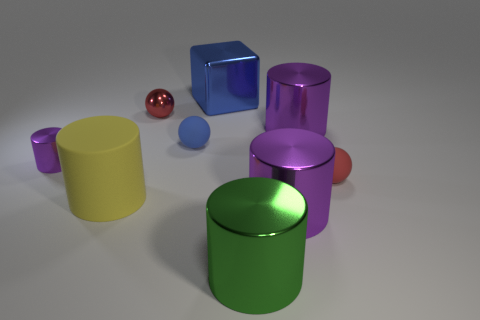Subtract all red blocks. How many purple cylinders are left? 3 Subtract all green cylinders. How many cylinders are left? 4 Subtract all rubber cylinders. How many cylinders are left? 4 Subtract all brown cylinders. Subtract all cyan cubes. How many cylinders are left? 5 Subtract all cylinders. How many objects are left? 4 Subtract all large yellow things. Subtract all big purple shiny cylinders. How many objects are left? 6 Add 2 yellow things. How many yellow things are left? 3 Add 1 tiny cylinders. How many tiny cylinders exist? 2 Subtract 0 red cubes. How many objects are left? 9 